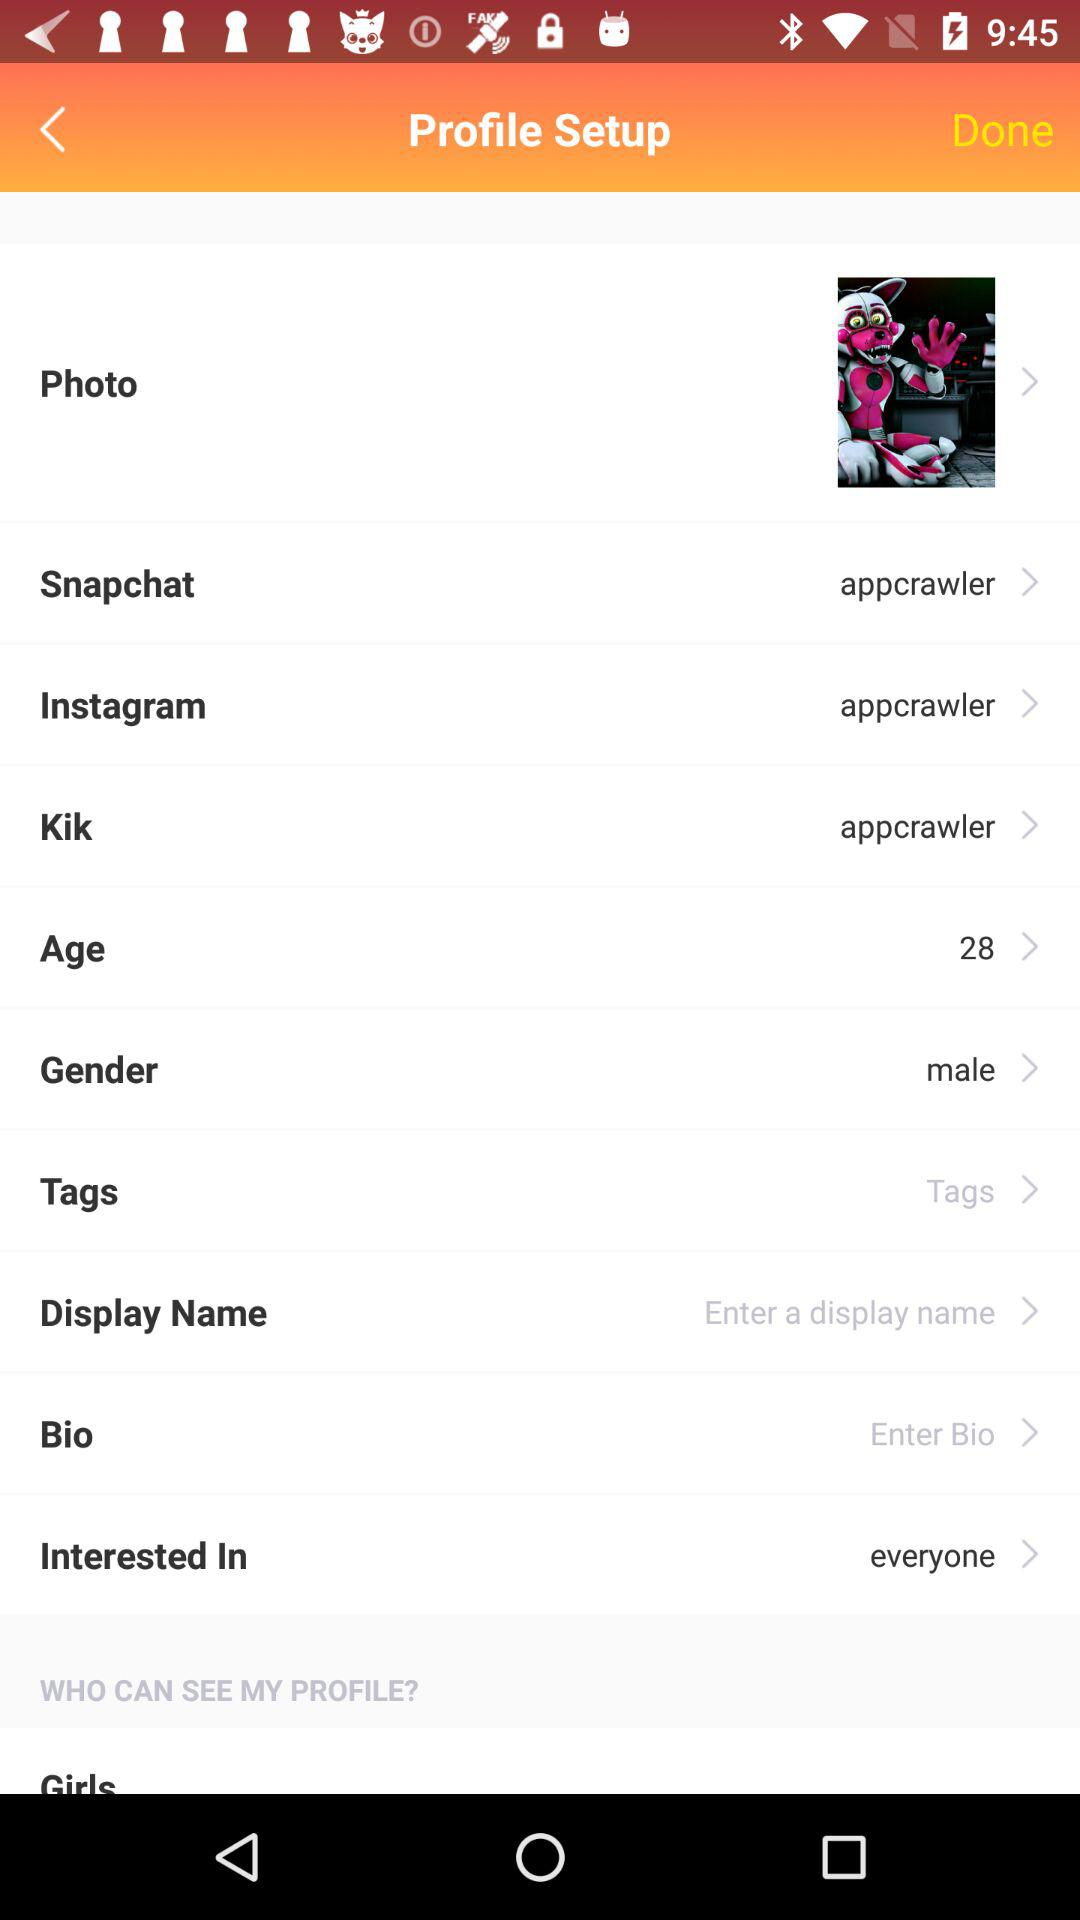Which option is selected in "Interested In"? The selected option is "everyone". 